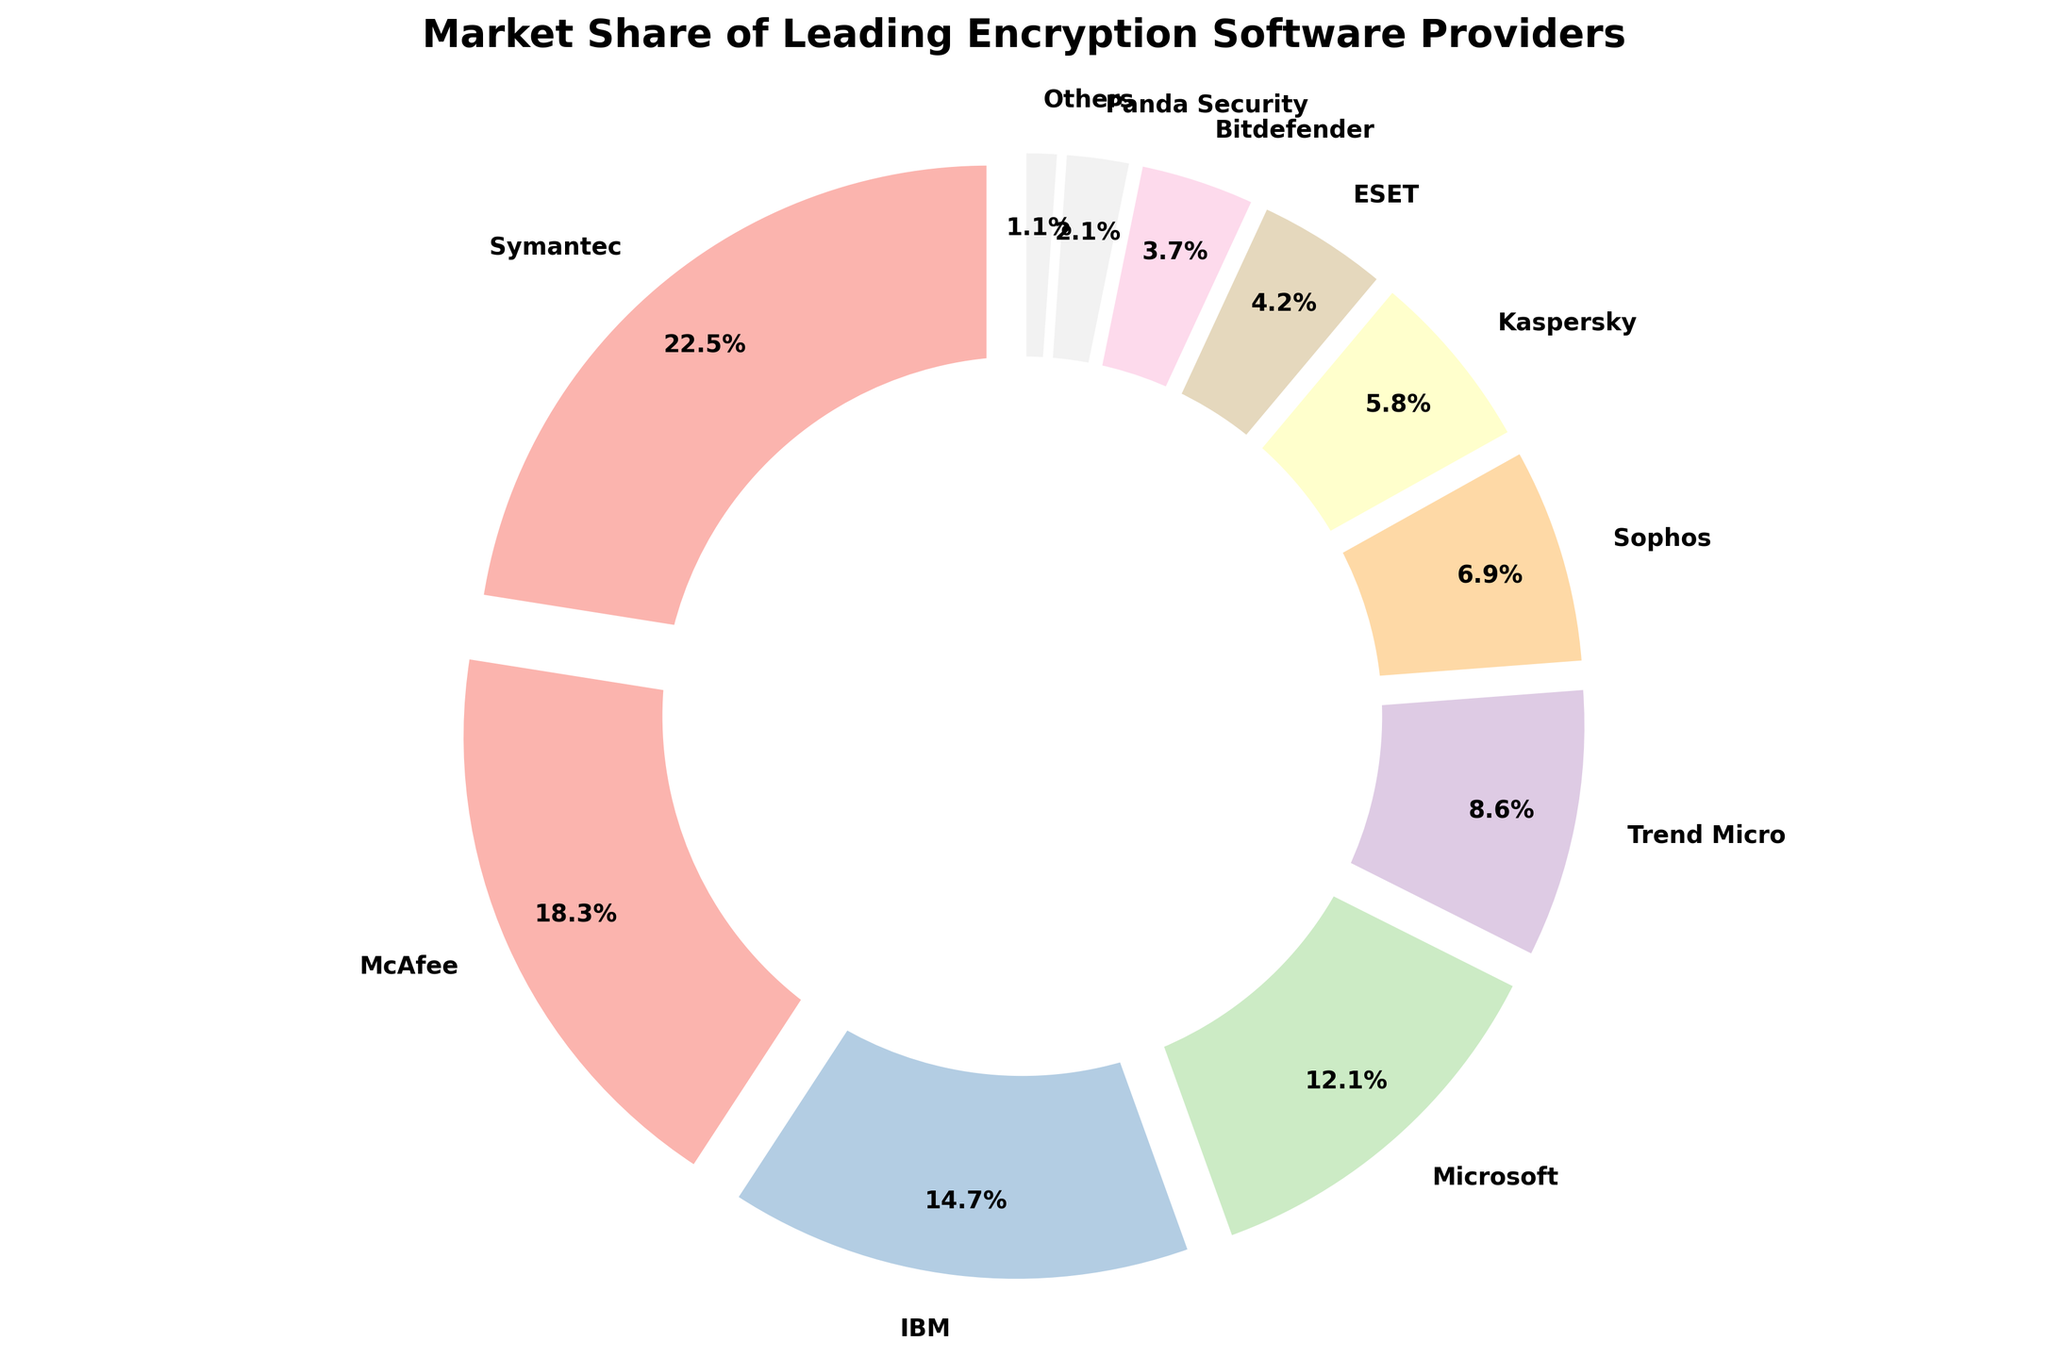Which software provider has the largest market share? The pie chart lists Symantec as having the largest segment, with its market share shown to be 22.5%.
Answer: Symantec What is the combined market share of IBM and Microsoft? The market share of IBM is 14.7% and Microsoft is 12.1%. Adding these two percentages together gives 14.7% + 12.1% = 26.8%.
Answer: 26.8% How much more market share does Symantec have compared to Trend Micro? Symantec has 22.5% market share, and Trend Micro has 8.6%. The difference is 22.5% - 8.6% = 13.9%.
Answer: 13.9% Which two companies have the closest market shares? By observing the pie chart, Microsoft (12.1%) and Trend Micro (8.6%) have a difference of 3.5%, whereas Sophos (6.9%) and Kaspersky (5.8%) have a smaller difference of 1.1%, which is the smallest difference among the listed companies.
Answer: Sophos and Kaspersky What can be said about the market share of providers categorized as Others? The segment labeled "Others" has a market share of 1.1%, clearly indicated in the chart and is the smallest compared to any individual company listed.
Answer: 1.1% What is the total market share of the top 3 providers? The top 3 providers listed are Symantec (22.5%), McAfee (18.3%), and IBM (14.7%). Adding these percentages together yields 22.5% + 18.3% + 14.7% = 55.5%.
Answer: 55.5% Which software provider has a larger market share, ESET or Bitdefender, and by how much? ESET has a 4.2% market share, while Bitdefender has 3.7%. The difference is 4.2% - 3.7% = 0.5%.
Answer: ESET, 0.5% Compare the total market share of Kaspersky and Bitdefender with McAfee's market share. The market shares of Kaspersky and Bitdefender are 5.8% and 3.7%, respectively, totaling 9.5%. McAfee has a single 18.3% share, so McAfee's market share exceeds their combined total by 18.3% - 9.5% = 8.8%.
Answer: McAfee is 8.8% higher Does any single company's market share exceed the combined market share of Sophos and ESET? Sophos has a market share of 6.9% and ESET has 4.2%. Combined, this is 6.9% + 4.2% = 11.1%. Symantec, with a 22.5% share, exceeds this combined total.
Answer: Yes How does the market share of Panda Security compare to the combined market share of "Others"? Panda Security has a market share of 2.1%, while "Others" collectively have 1.1%. Panda Security's market share is larger by 2.1% - 1.1% = 1.0%.
Answer: Panda Security is 1.0% higher 